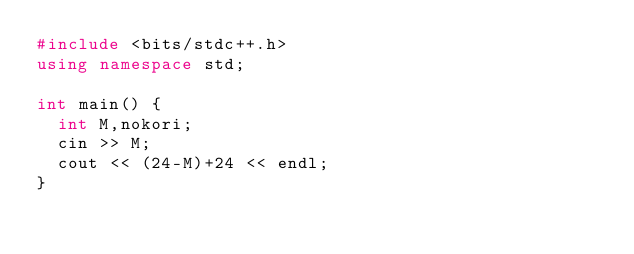Convert code to text. <code><loc_0><loc_0><loc_500><loc_500><_C++_>#include <bits/stdc++.h>
using namespace std;

int main() {
  int M,nokori;
  cin >> M;
  cout << (24-M)+24 << endl;
}
</code> 